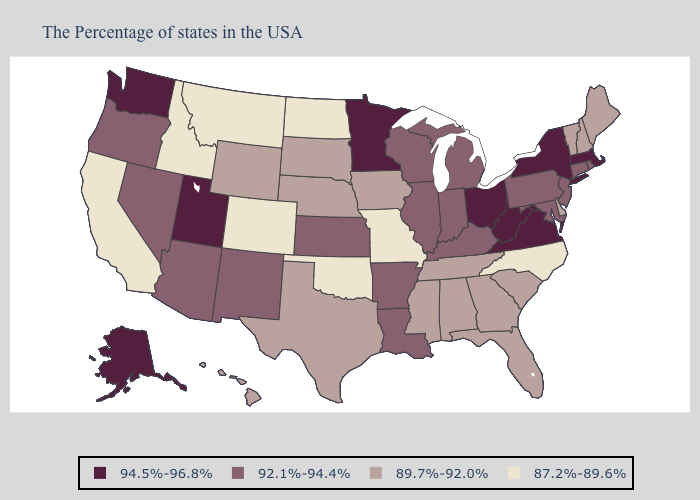Does the first symbol in the legend represent the smallest category?
Short answer required. No. Name the states that have a value in the range 92.1%-94.4%?
Quick response, please. Rhode Island, Connecticut, New Jersey, Maryland, Pennsylvania, Michigan, Kentucky, Indiana, Wisconsin, Illinois, Louisiana, Arkansas, Kansas, New Mexico, Arizona, Nevada, Oregon. Name the states that have a value in the range 94.5%-96.8%?
Write a very short answer. Massachusetts, New York, Virginia, West Virginia, Ohio, Minnesota, Utah, Washington, Alaska. Which states have the lowest value in the USA?
Keep it brief. North Carolina, Missouri, Oklahoma, North Dakota, Colorado, Montana, Idaho, California. Does Oregon have the highest value in the USA?
Quick response, please. No. Does Maryland have the highest value in the USA?
Write a very short answer. No. Is the legend a continuous bar?
Short answer required. No. Name the states that have a value in the range 89.7%-92.0%?
Concise answer only. Maine, New Hampshire, Vermont, Delaware, South Carolina, Florida, Georgia, Alabama, Tennessee, Mississippi, Iowa, Nebraska, Texas, South Dakota, Wyoming, Hawaii. What is the value of Nebraska?
Quick response, please. 89.7%-92.0%. Does North Dakota have a lower value than Missouri?
Quick response, please. No. Which states have the lowest value in the West?
Be succinct. Colorado, Montana, Idaho, California. Which states have the highest value in the USA?
Quick response, please. Massachusetts, New York, Virginia, West Virginia, Ohio, Minnesota, Utah, Washington, Alaska. What is the value of Pennsylvania?
Give a very brief answer. 92.1%-94.4%. Name the states that have a value in the range 87.2%-89.6%?
Quick response, please. North Carolina, Missouri, Oklahoma, North Dakota, Colorado, Montana, Idaho, California. 